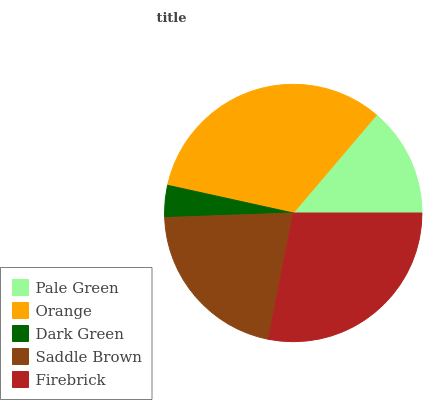Is Dark Green the minimum?
Answer yes or no. Yes. Is Orange the maximum?
Answer yes or no. Yes. Is Orange the minimum?
Answer yes or no. No. Is Dark Green the maximum?
Answer yes or no. No. Is Orange greater than Dark Green?
Answer yes or no. Yes. Is Dark Green less than Orange?
Answer yes or no. Yes. Is Dark Green greater than Orange?
Answer yes or no. No. Is Orange less than Dark Green?
Answer yes or no. No. Is Saddle Brown the high median?
Answer yes or no. Yes. Is Saddle Brown the low median?
Answer yes or no. Yes. Is Orange the high median?
Answer yes or no. No. Is Firebrick the low median?
Answer yes or no. No. 